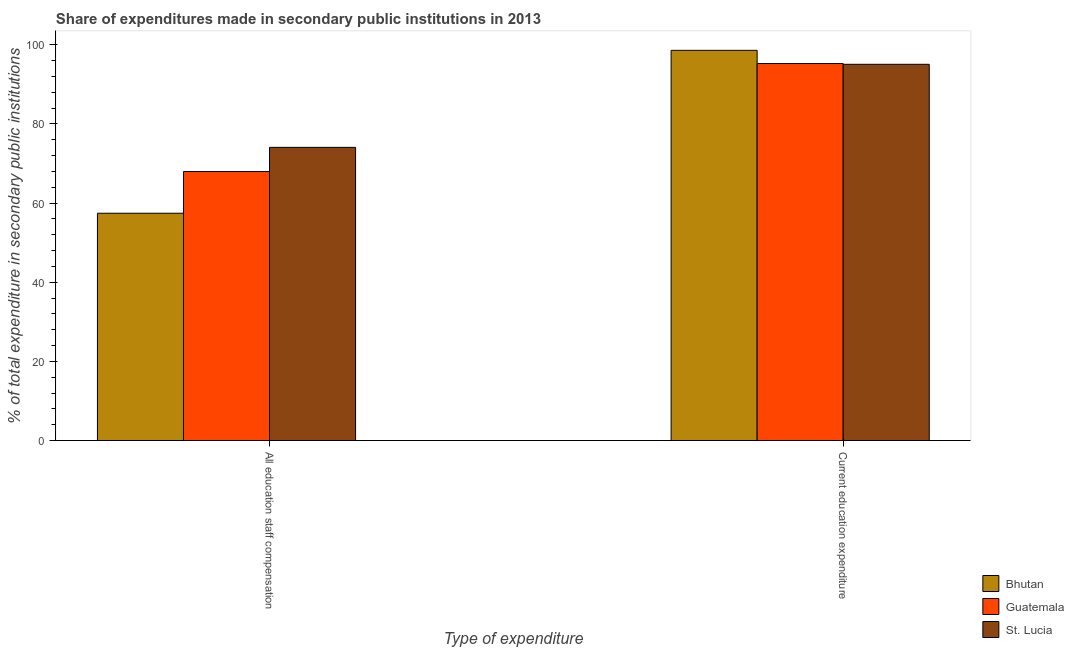How many different coloured bars are there?
Your answer should be very brief. 3. How many bars are there on the 2nd tick from the right?
Your response must be concise. 3. What is the label of the 2nd group of bars from the left?
Your answer should be very brief. Current education expenditure. What is the expenditure in education in Bhutan?
Offer a very short reply. 98.58. Across all countries, what is the maximum expenditure in staff compensation?
Offer a very short reply. 74.07. Across all countries, what is the minimum expenditure in staff compensation?
Make the answer very short. 57.43. In which country was the expenditure in staff compensation maximum?
Ensure brevity in your answer.  St. Lucia. In which country was the expenditure in staff compensation minimum?
Give a very brief answer. Bhutan. What is the total expenditure in staff compensation in the graph?
Make the answer very short. 199.46. What is the difference between the expenditure in staff compensation in St. Lucia and that in Guatemala?
Ensure brevity in your answer.  6.1. What is the difference between the expenditure in education in Bhutan and the expenditure in staff compensation in Guatemala?
Your response must be concise. 30.61. What is the average expenditure in education per country?
Provide a succinct answer. 96.29. What is the difference between the expenditure in education and expenditure in staff compensation in Bhutan?
Offer a very short reply. 41.15. What is the ratio of the expenditure in staff compensation in St. Lucia to that in Bhutan?
Make the answer very short. 1.29. In how many countries, is the expenditure in education greater than the average expenditure in education taken over all countries?
Keep it short and to the point. 1. What does the 2nd bar from the left in All education staff compensation represents?
Make the answer very short. Guatemala. What does the 3rd bar from the right in All education staff compensation represents?
Provide a short and direct response. Bhutan. Are all the bars in the graph horizontal?
Keep it short and to the point. No. How many countries are there in the graph?
Your response must be concise. 3. Does the graph contain grids?
Your answer should be compact. No. How many legend labels are there?
Your response must be concise. 3. What is the title of the graph?
Give a very brief answer. Share of expenditures made in secondary public institutions in 2013. Does "Kazakhstan" appear as one of the legend labels in the graph?
Ensure brevity in your answer.  No. What is the label or title of the X-axis?
Provide a succinct answer. Type of expenditure. What is the label or title of the Y-axis?
Provide a short and direct response. % of total expenditure in secondary public institutions. What is the % of total expenditure in secondary public institutions in Bhutan in All education staff compensation?
Your answer should be compact. 57.43. What is the % of total expenditure in secondary public institutions of Guatemala in All education staff compensation?
Your answer should be compact. 67.96. What is the % of total expenditure in secondary public institutions of St. Lucia in All education staff compensation?
Give a very brief answer. 74.07. What is the % of total expenditure in secondary public institutions in Bhutan in Current education expenditure?
Your answer should be very brief. 98.58. What is the % of total expenditure in secondary public institutions in Guatemala in Current education expenditure?
Give a very brief answer. 95.25. What is the % of total expenditure in secondary public institutions of St. Lucia in Current education expenditure?
Provide a succinct answer. 95.05. Across all Type of expenditure, what is the maximum % of total expenditure in secondary public institutions in Bhutan?
Provide a short and direct response. 98.58. Across all Type of expenditure, what is the maximum % of total expenditure in secondary public institutions in Guatemala?
Make the answer very short. 95.25. Across all Type of expenditure, what is the maximum % of total expenditure in secondary public institutions in St. Lucia?
Provide a succinct answer. 95.05. Across all Type of expenditure, what is the minimum % of total expenditure in secondary public institutions of Bhutan?
Offer a very short reply. 57.43. Across all Type of expenditure, what is the minimum % of total expenditure in secondary public institutions of Guatemala?
Provide a succinct answer. 67.96. Across all Type of expenditure, what is the minimum % of total expenditure in secondary public institutions in St. Lucia?
Give a very brief answer. 74.07. What is the total % of total expenditure in secondary public institutions in Bhutan in the graph?
Your response must be concise. 156. What is the total % of total expenditure in secondary public institutions in Guatemala in the graph?
Provide a short and direct response. 163.21. What is the total % of total expenditure in secondary public institutions in St. Lucia in the graph?
Your answer should be compact. 169.12. What is the difference between the % of total expenditure in secondary public institutions in Bhutan in All education staff compensation and that in Current education expenditure?
Keep it short and to the point. -41.15. What is the difference between the % of total expenditure in secondary public institutions in Guatemala in All education staff compensation and that in Current education expenditure?
Your answer should be compact. -27.28. What is the difference between the % of total expenditure in secondary public institutions in St. Lucia in All education staff compensation and that in Current education expenditure?
Ensure brevity in your answer.  -20.98. What is the difference between the % of total expenditure in secondary public institutions in Bhutan in All education staff compensation and the % of total expenditure in secondary public institutions in Guatemala in Current education expenditure?
Offer a very short reply. -37.82. What is the difference between the % of total expenditure in secondary public institutions of Bhutan in All education staff compensation and the % of total expenditure in secondary public institutions of St. Lucia in Current education expenditure?
Make the answer very short. -37.62. What is the difference between the % of total expenditure in secondary public institutions of Guatemala in All education staff compensation and the % of total expenditure in secondary public institutions of St. Lucia in Current education expenditure?
Keep it short and to the point. -27.08. What is the average % of total expenditure in secondary public institutions in Bhutan per Type of expenditure?
Ensure brevity in your answer.  78. What is the average % of total expenditure in secondary public institutions in Guatemala per Type of expenditure?
Give a very brief answer. 81.61. What is the average % of total expenditure in secondary public institutions of St. Lucia per Type of expenditure?
Your answer should be very brief. 84.56. What is the difference between the % of total expenditure in secondary public institutions of Bhutan and % of total expenditure in secondary public institutions of Guatemala in All education staff compensation?
Provide a short and direct response. -10.54. What is the difference between the % of total expenditure in secondary public institutions in Bhutan and % of total expenditure in secondary public institutions in St. Lucia in All education staff compensation?
Give a very brief answer. -16.64. What is the difference between the % of total expenditure in secondary public institutions in Guatemala and % of total expenditure in secondary public institutions in St. Lucia in All education staff compensation?
Your response must be concise. -6.1. What is the difference between the % of total expenditure in secondary public institutions of Bhutan and % of total expenditure in secondary public institutions of Guatemala in Current education expenditure?
Provide a short and direct response. 3.33. What is the difference between the % of total expenditure in secondary public institutions in Bhutan and % of total expenditure in secondary public institutions in St. Lucia in Current education expenditure?
Give a very brief answer. 3.53. What is the difference between the % of total expenditure in secondary public institutions in Guatemala and % of total expenditure in secondary public institutions in St. Lucia in Current education expenditure?
Make the answer very short. 0.2. What is the ratio of the % of total expenditure in secondary public institutions of Bhutan in All education staff compensation to that in Current education expenditure?
Give a very brief answer. 0.58. What is the ratio of the % of total expenditure in secondary public institutions of Guatemala in All education staff compensation to that in Current education expenditure?
Provide a short and direct response. 0.71. What is the ratio of the % of total expenditure in secondary public institutions of St. Lucia in All education staff compensation to that in Current education expenditure?
Provide a short and direct response. 0.78. What is the difference between the highest and the second highest % of total expenditure in secondary public institutions of Bhutan?
Give a very brief answer. 41.15. What is the difference between the highest and the second highest % of total expenditure in secondary public institutions of Guatemala?
Your answer should be very brief. 27.28. What is the difference between the highest and the second highest % of total expenditure in secondary public institutions in St. Lucia?
Your answer should be compact. 20.98. What is the difference between the highest and the lowest % of total expenditure in secondary public institutions of Bhutan?
Your answer should be compact. 41.15. What is the difference between the highest and the lowest % of total expenditure in secondary public institutions of Guatemala?
Keep it short and to the point. 27.28. What is the difference between the highest and the lowest % of total expenditure in secondary public institutions of St. Lucia?
Offer a very short reply. 20.98. 